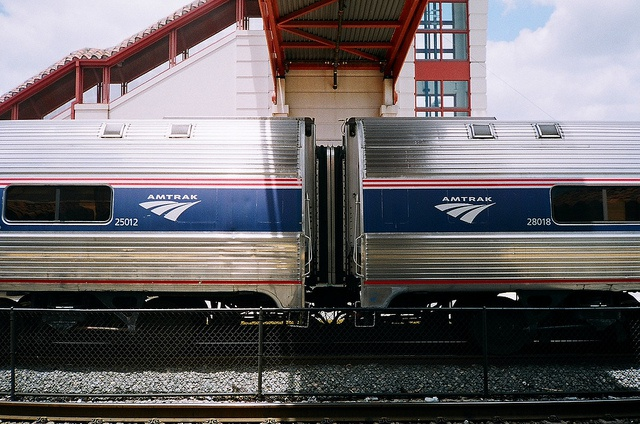Describe the objects in this image and their specific colors. I can see a train in lavender, black, gray, and darkgray tones in this image. 